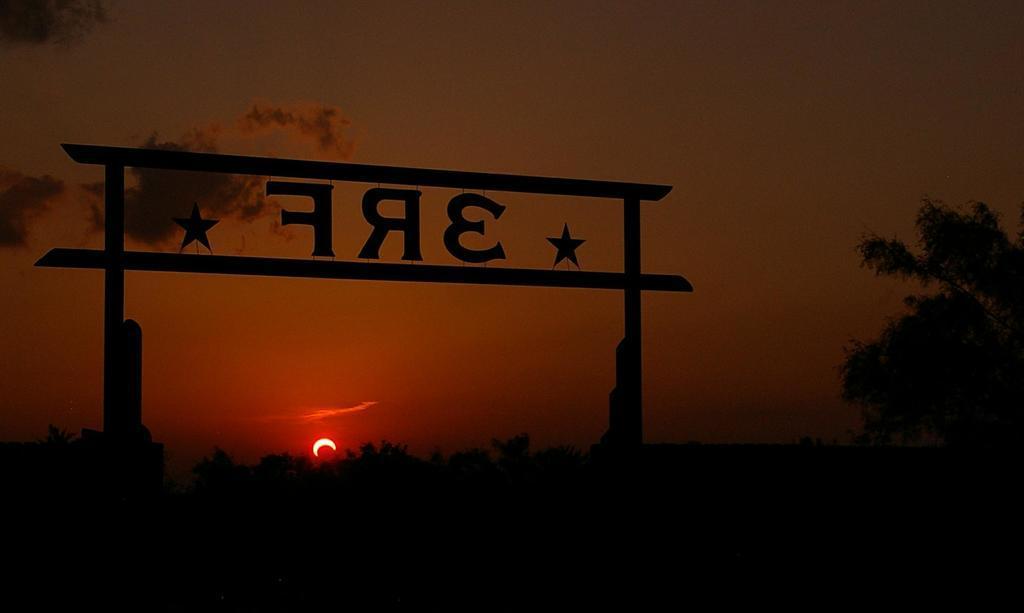Please provide a concise description of this image. In this image we can see an arch with text on it, there are plants, trees, also we can see the sun, and the cloudy sky. 